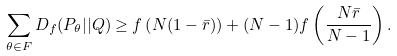Convert formula to latex. <formula><loc_0><loc_0><loc_500><loc_500>\sum _ { \theta \in F } D _ { f } ( P _ { \theta } | | Q ) \geq f \left ( N ( 1 - \bar { r } ) \right ) + ( N - 1 ) f \left ( \frac { N \bar { r } } { N - 1 } \right ) .</formula> 